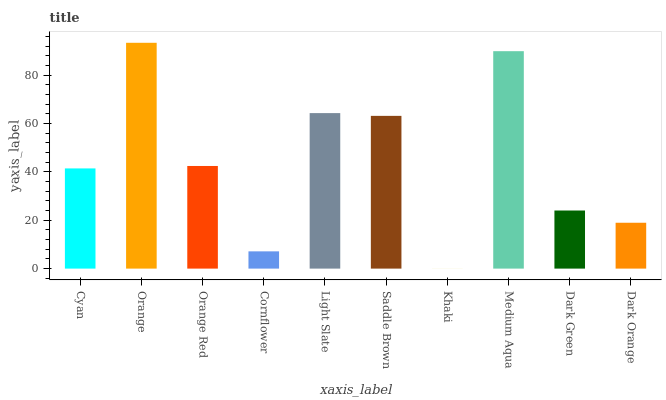Is Khaki the minimum?
Answer yes or no. Yes. Is Orange the maximum?
Answer yes or no. Yes. Is Orange Red the minimum?
Answer yes or no. No. Is Orange Red the maximum?
Answer yes or no. No. Is Orange greater than Orange Red?
Answer yes or no. Yes. Is Orange Red less than Orange?
Answer yes or no. Yes. Is Orange Red greater than Orange?
Answer yes or no. No. Is Orange less than Orange Red?
Answer yes or no. No. Is Orange Red the high median?
Answer yes or no. Yes. Is Cyan the low median?
Answer yes or no. Yes. Is Medium Aqua the high median?
Answer yes or no. No. Is Khaki the low median?
Answer yes or no. No. 